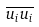Convert formula to latex. <formula><loc_0><loc_0><loc_500><loc_500>\overline { u _ { i } u _ { i } }</formula> 